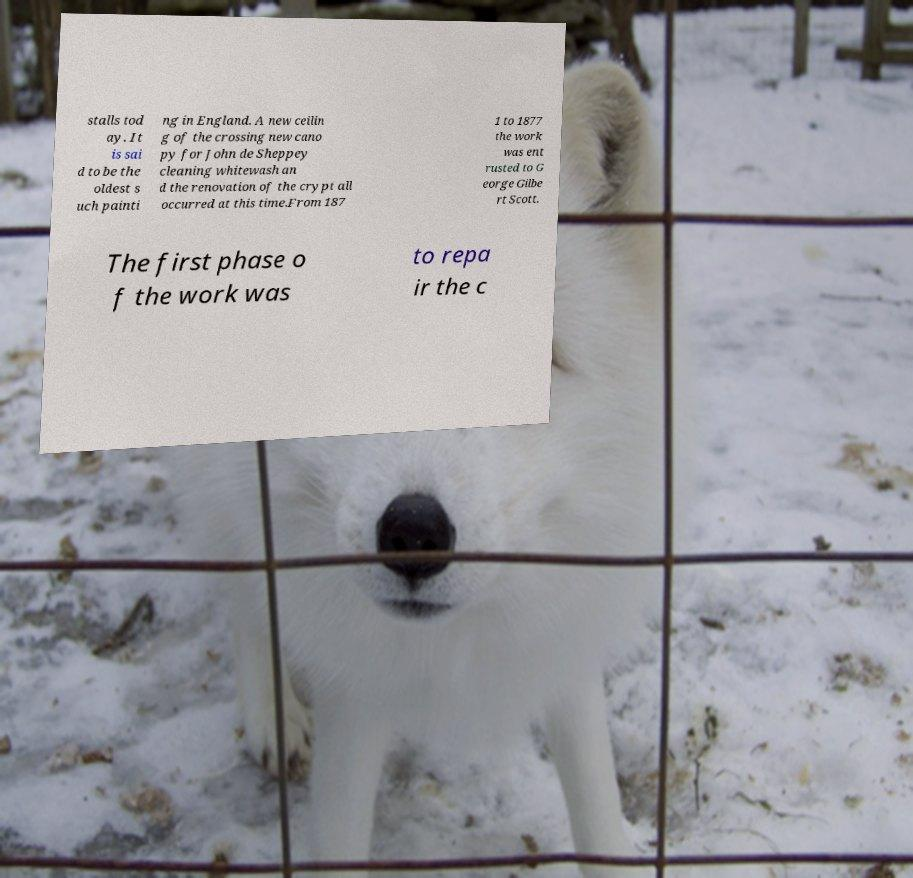Could you extract and type out the text from this image? stalls tod ay. It is sai d to be the oldest s uch painti ng in England. A new ceilin g of the crossing new cano py for John de Sheppey cleaning whitewash an d the renovation of the crypt all occurred at this time.From 187 1 to 1877 the work was ent rusted to G eorge Gilbe rt Scott. The first phase o f the work was to repa ir the c 